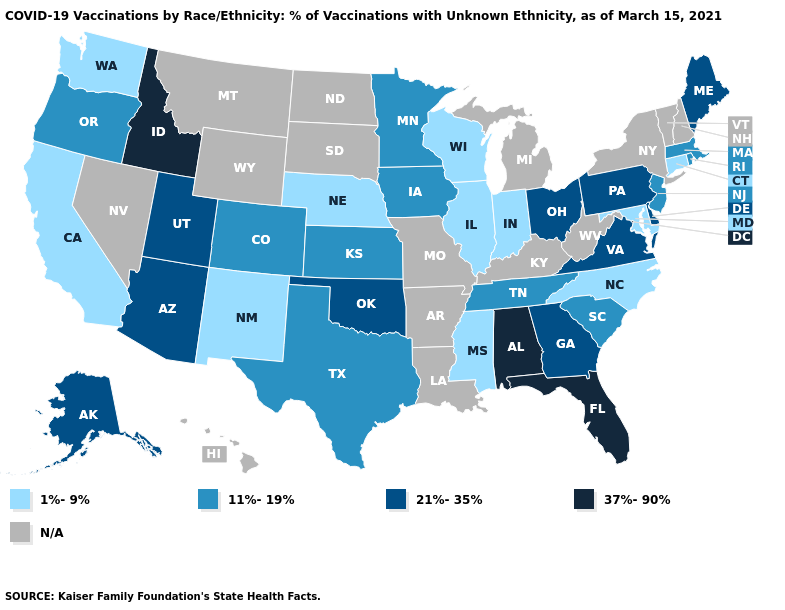Name the states that have a value in the range 1%-9%?
Be succinct. California, Connecticut, Illinois, Indiana, Maryland, Mississippi, Nebraska, New Mexico, North Carolina, Washington, Wisconsin. What is the lowest value in the South?
Write a very short answer. 1%-9%. What is the highest value in states that border Oklahoma?
Keep it brief. 11%-19%. Does the first symbol in the legend represent the smallest category?
Give a very brief answer. Yes. How many symbols are there in the legend?
Keep it brief. 5. Does the first symbol in the legend represent the smallest category?
Write a very short answer. Yes. What is the value of Nebraska?
Keep it brief. 1%-9%. Name the states that have a value in the range 21%-35%?
Concise answer only. Alaska, Arizona, Delaware, Georgia, Maine, Ohio, Oklahoma, Pennsylvania, Utah, Virginia. Name the states that have a value in the range 21%-35%?
Short answer required. Alaska, Arizona, Delaware, Georgia, Maine, Ohio, Oklahoma, Pennsylvania, Utah, Virginia. Does Ohio have the highest value in the MidWest?
Answer briefly. Yes. Among the states that border Arkansas , does Oklahoma have the highest value?
Short answer required. Yes. What is the value of Nevada?
Write a very short answer. N/A. 